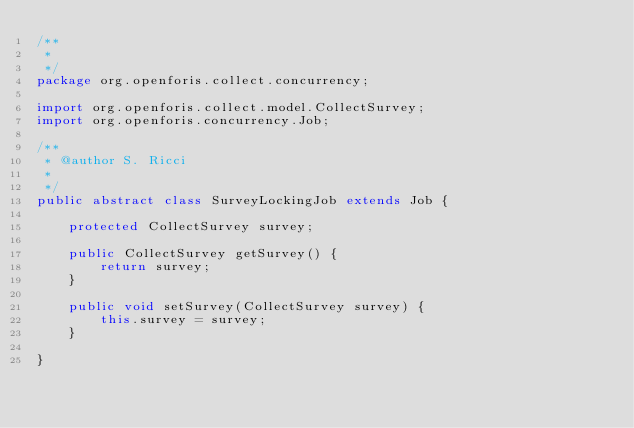Convert code to text. <code><loc_0><loc_0><loc_500><loc_500><_Java_>/**
 * 
 */
package org.openforis.collect.concurrency;

import org.openforis.collect.model.CollectSurvey;
import org.openforis.concurrency.Job;

/**
 * @author S. Ricci
 *
 */
public abstract class SurveyLockingJob extends Job {

	protected CollectSurvey survey;
	
	public CollectSurvey getSurvey() {
		return survey;
	}
	
	public void setSurvey(CollectSurvey survey) {
		this.survey = survey;
	}

}
</code> 